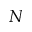Convert formula to latex. <formula><loc_0><loc_0><loc_500><loc_500>N</formula> 